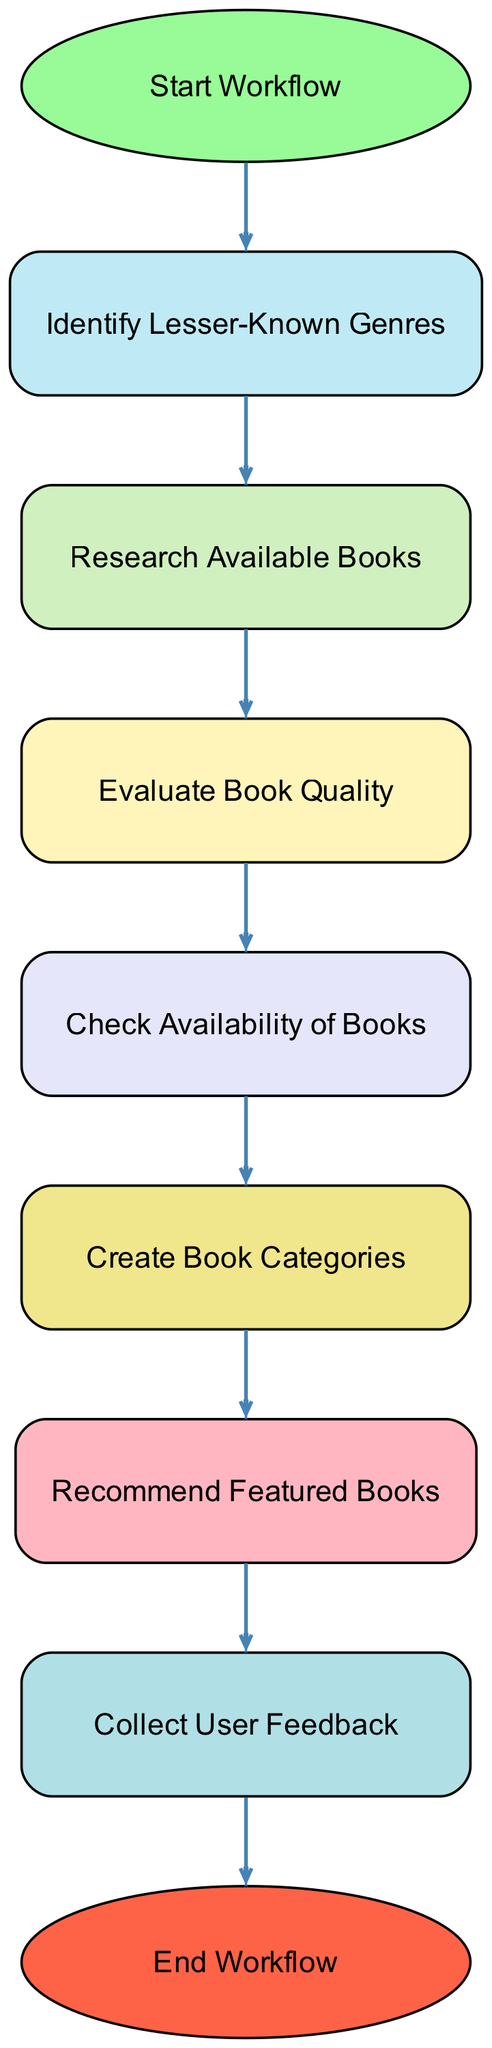What is the first step in the workflow? The diagram indicates that the first step is labeled "Start Workflow," which initiates the categorization process.
Answer: Start Workflow How many nodes are in the diagram? By counting the labeled elements in the diagram, we can see there are nine nodes representing various steps in the workflow.
Answer: Nine What is the last step before the end? The last step before reaching the "End Workflow" node is "Collect User Feedback," which is essential for assessing the recommendations made.
Answer: Collect User Feedback Which node follows "Check Availability of Books"? According to the diagram's flow, the node that follows "Check Availability of Books" is "Create Book Categories," indicating what should be done after verifying availability.
Answer: Create Book Categories What color is the "Research Available Books" node? The node "Research Available Books" is filled with a light blue color as indicated in the color coding of the diagram for the nodes.
Answer: Light blue What are the connections leading out from "Evaluate Book Quality"? The "Evaluate Book Quality" node has a connection leading to "Check Availability of Books," indicating the sequential process that follows after evaluating quality.
Answer: Check Availability of Books How many connections are in the diagram? The diagram contains eight connections, which represent the directional flow from one step to another in the workflow.
Answer: Eight What is the relationship between "Identify Lesser-Known Genres" and "Research Available Books"? The relationship is a direct connection where "Identify Lesser-Known Genres" leads to "Research Available Books," illustrating that identification initiates the research phase.
Answer: Direct connection Which step is directly before "Recommend Featured Books"? According to the flow represented in the diagram, "Create Book Categories" is the step that directly precedes "Recommend Featured Books."
Answer: Create Book Categories 